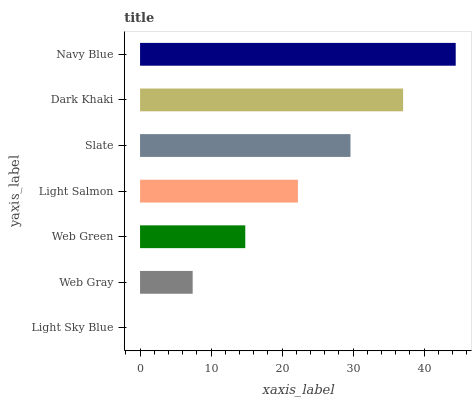Is Light Sky Blue the minimum?
Answer yes or no. Yes. Is Navy Blue the maximum?
Answer yes or no. Yes. Is Web Gray the minimum?
Answer yes or no. No. Is Web Gray the maximum?
Answer yes or no. No. Is Web Gray greater than Light Sky Blue?
Answer yes or no. Yes. Is Light Sky Blue less than Web Gray?
Answer yes or no. Yes. Is Light Sky Blue greater than Web Gray?
Answer yes or no. No. Is Web Gray less than Light Sky Blue?
Answer yes or no. No. Is Light Salmon the high median?
Answer yes or no. Yes. Is Light Salmon the low median?
Answer yes or no. Yes. Is Web Green the high median?
Answer yes or no. No. Is Navy Blue the low median?
Answer yes or no. No. 